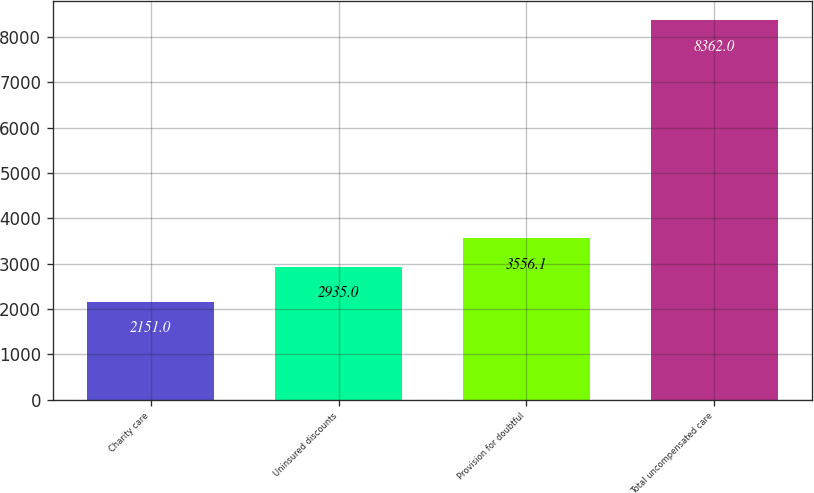<chart> <loc_0><loc_0><loc_500><loc_500><bar_chart><fcel>Charity care<fcel>Uninsured discounts<fcel>Provision for doubtful<fcel>Total uncompensated care<nl><fcel>2151<fcel>2935<fcel>3556.1<fcel>8362<nl></chart> 